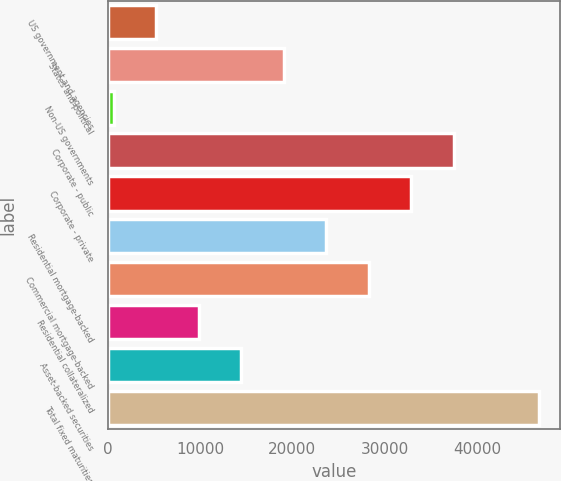<chart> <loc_0><loc_0><loc_500><loc_500><bar_chart><fcel>US government and agencies<fcel>States and political<fcel>Non-US governments<fcel>Corporate - public<fcel>Corporate - private<fcel>Residential mortgage-backed<fcel>Commercial mortgage-backed<fcel>Residential collateralized<fcel>Asset-backed securities<fcel>Total fixed maturities<nl><fcel>5279.42<fcel>19089.4<fcel>676.1<fcel>37502.7<fcel>32899.3<fcel>23692.7<fcel>28296<fcel>9882.74<fcel>14486.1<fcel>46709.3<nl></chart> 